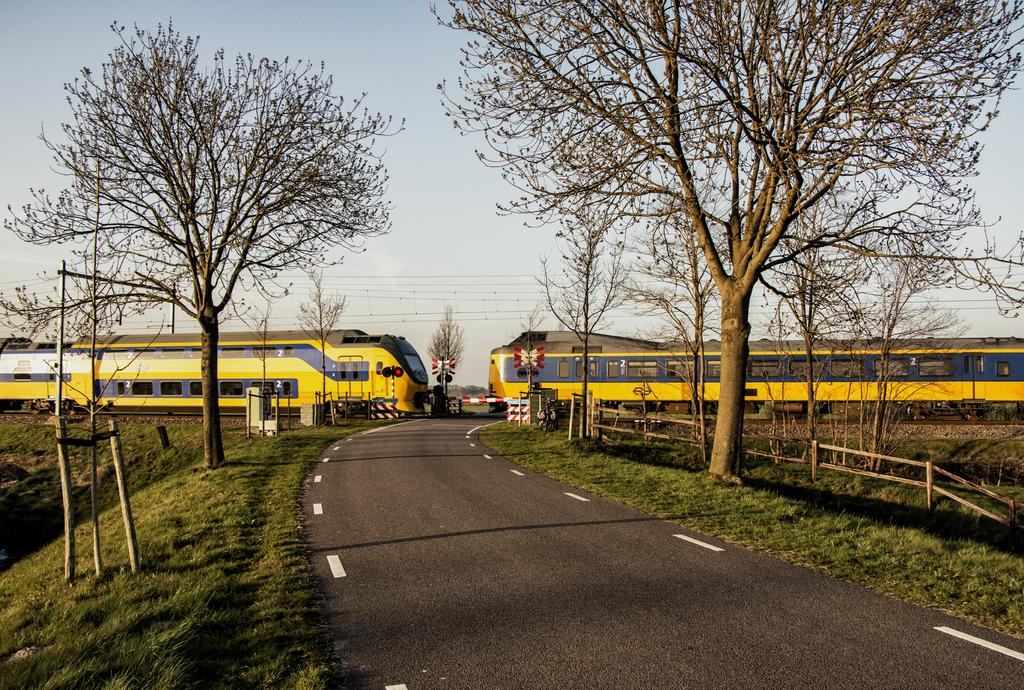What is the main feature of the image? There is a road in the image. What can be seen on both sides of the road? Grassy land and trees are present on both sides of the road. What type of vehicle is in the image? There is an electrical train in the image. What is the color of the electrical train? The electrical train is yellow in color. What type of relation can be seen between the company and the beam in the image? There is no mention of a company or a beam in the image. 